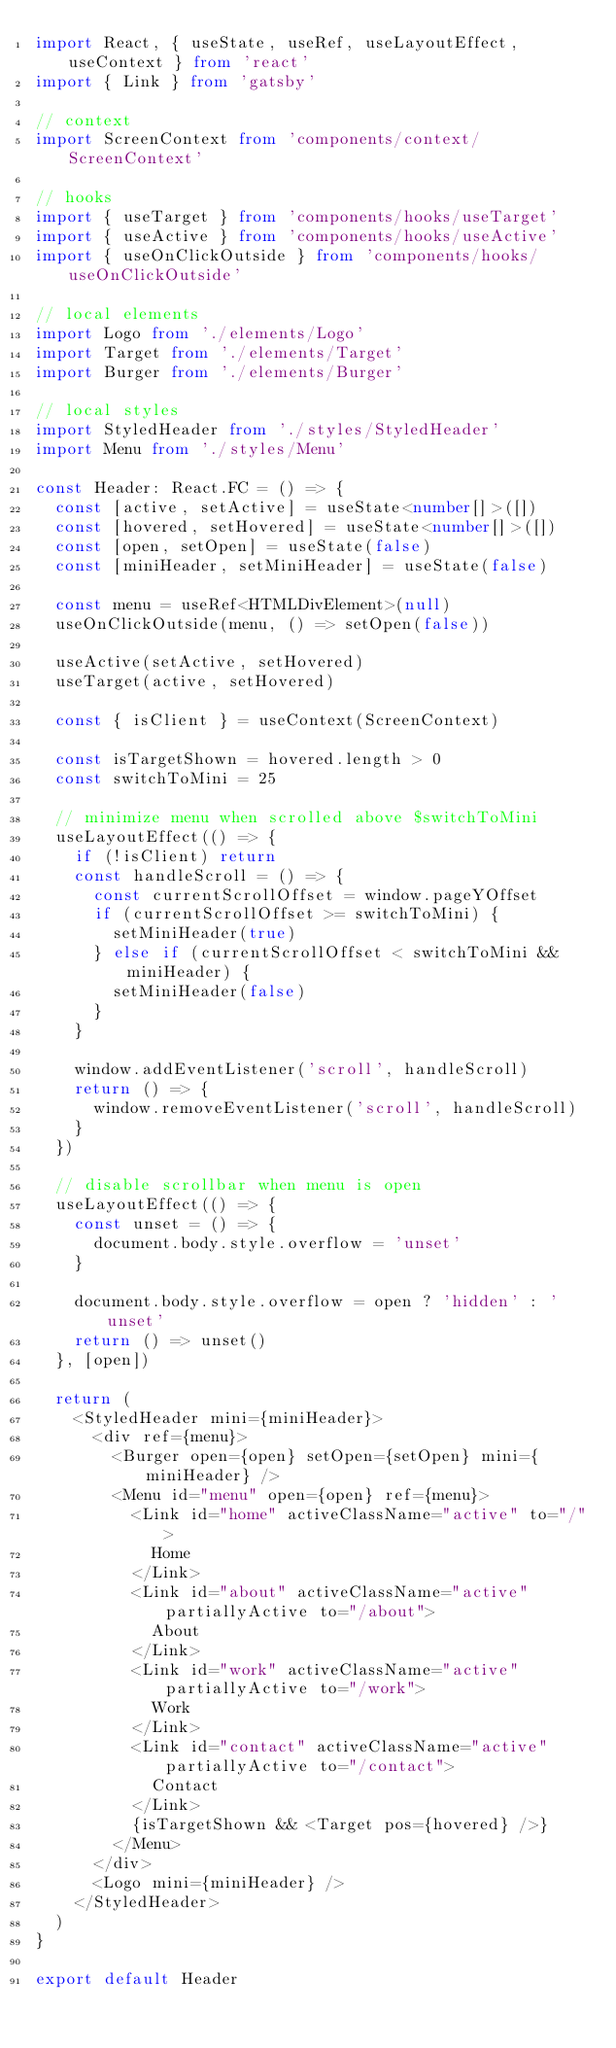<code> <loc_0><loc_0><loc_500><loc_500><_TypeScript_>import React, { useState, useRef, useLayoutEffect, useContext } from 'react'
import { Link } from 'gatsby'

// context
import ScreenContext from 'components/context/ScreenContext'

// hooks
import { useTarget } from 'components/hooks/useTarget'
import { useActive } from 'components/hooks/useActive'
import { useOnClickOutside } from 'components/hooks/useOnClickOutside'

// local elements
import Logo from './elements/Logo'
import Target from './elements/Target'
import Burger from './elements/Burger'

// local styles
import StyledHeader from './styles/StyledHeader'
import Menu from './styles/Menu'

const Header: React.FC = () => {
  const [active, setActive] = useState<number[]>([])
  const [hovered, setHovered] = useState<number[]>([])
  const [open, setOpen] = useState(false)
  const [miniHeader, setMiniHeader] = useState(false)

  const menu = useRef<HTMLDivElement>(null)
  useOnClickOutside(menu, () => setOpen(false))

  useActive(setActive, setHovered)
  useTarget(active, setHovered)

  const { isClient } = useContext(ScreenContext)

  const isTargetShown = hovered.length > 0
  const switchToMini = 25

  // minimize menu when scrolled above $switchToMini
  useLayoutEffect(() => {
    if (!isClient) return
    const handleScroll = () => {
      const currentScrollOffset = window.pageYOffset
      if (currentScrollOffset >= switchToMini) {
        setMiniHeader(true)
      } else if (currentScrollOffset < switchToMini && miniHeader) {
        setMiniHeader(false)
      }
    }

    window.addEventListener('scroll', handleScroll)
    return () => {
      window.removeEventListener('scroll', handleScroll)
    }
  })

  // disable scrollbar when menu is open
  useLayoutEffect(() => {
    const unset = () => {
      document.body.style.overflow = 'unset'
    }

    document.body.style.overflow = open ? 'hidden' : 'unset'
    return () => unset()
  }, [open])

  return (
    <StyledHeader mini={miniHeader}>
      <div ref={menu}>
        <Burger open={open} setOpen={setOpen} mini={miniHeader} />
        <Menu id="menu" open={open} ref={menu}>
          <Link id="home" activeClassName="active" to="/">
            Home
          </Link>
          <Link id="about" activeClassName="active" partiallyActive to="/about">
            About
          </Link>
          <Link id="work" activeClassName="active" partiallyActive to="/work">
            Work
          </Link>
          <Link id="contact" activeClassName="active" partiallyActive to="/contact">
            Contact
          </Link>
          {isTargetShown && <Target pos={hovered} />}
        </Menu>
      </div>
      <Logo mini={miniHeader} />
    </StyledHeader>
  )
}

export default Header
</code> 